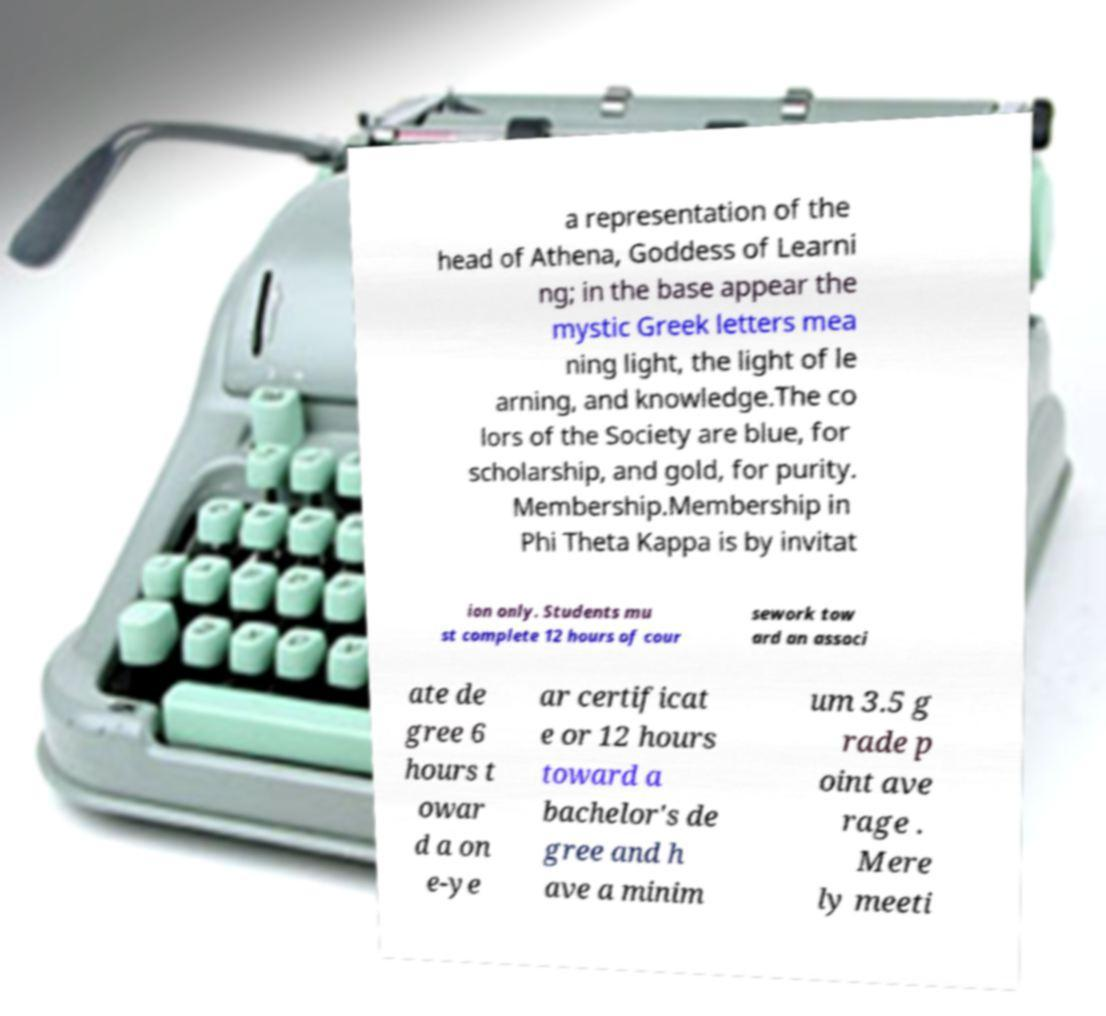Please identify and transcribe the text found in this image. a representation of the head of Athena, Goddess of Learni ng; in the base appear the mystic Greek letters mea ning light, the light of le arning, and knowledge.The co lors of the Society are blue, for scholarship, and gold, for purity. Membership.Membership in Phi Theta Kappa is by invitat ion only. Students mu st complete 12 hours of cour sework tow ard an associ ate de gree 6 hours t owar d a on e-ye ar certificat e or 12 hours toward a bachelor's de gree and h ave a minim um 3.5 g rade p oint ave rage . Mere ly meeti 